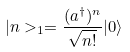<formula> <loc_0><loc_0><loc_500><loc_500>| n > _ { 1 } = \frac { ( a ^ { \dagger } ) ^ { n } } { \sqrt { n ! } } | 0 \rangle</formula> 